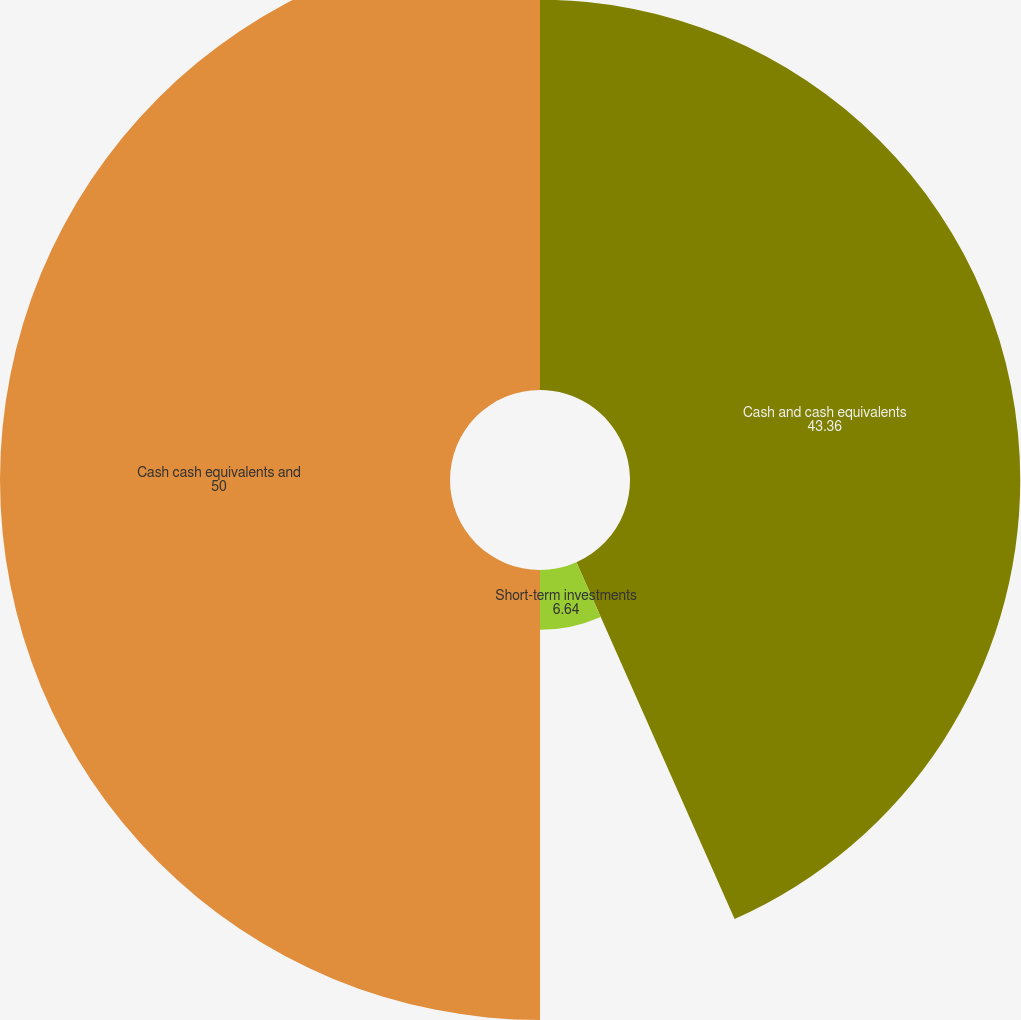Convert chart to OTSL. <chart><loc_0><loc_0><loc_500><loc_500><pie_chart><fcel>Cash and cash equivalents<fcel>Short-term investments<fcel>Cash cash equivalents and<nl><fcel>43.36%<fcel>6.64%<fcel>50.0%<nl></chart> 